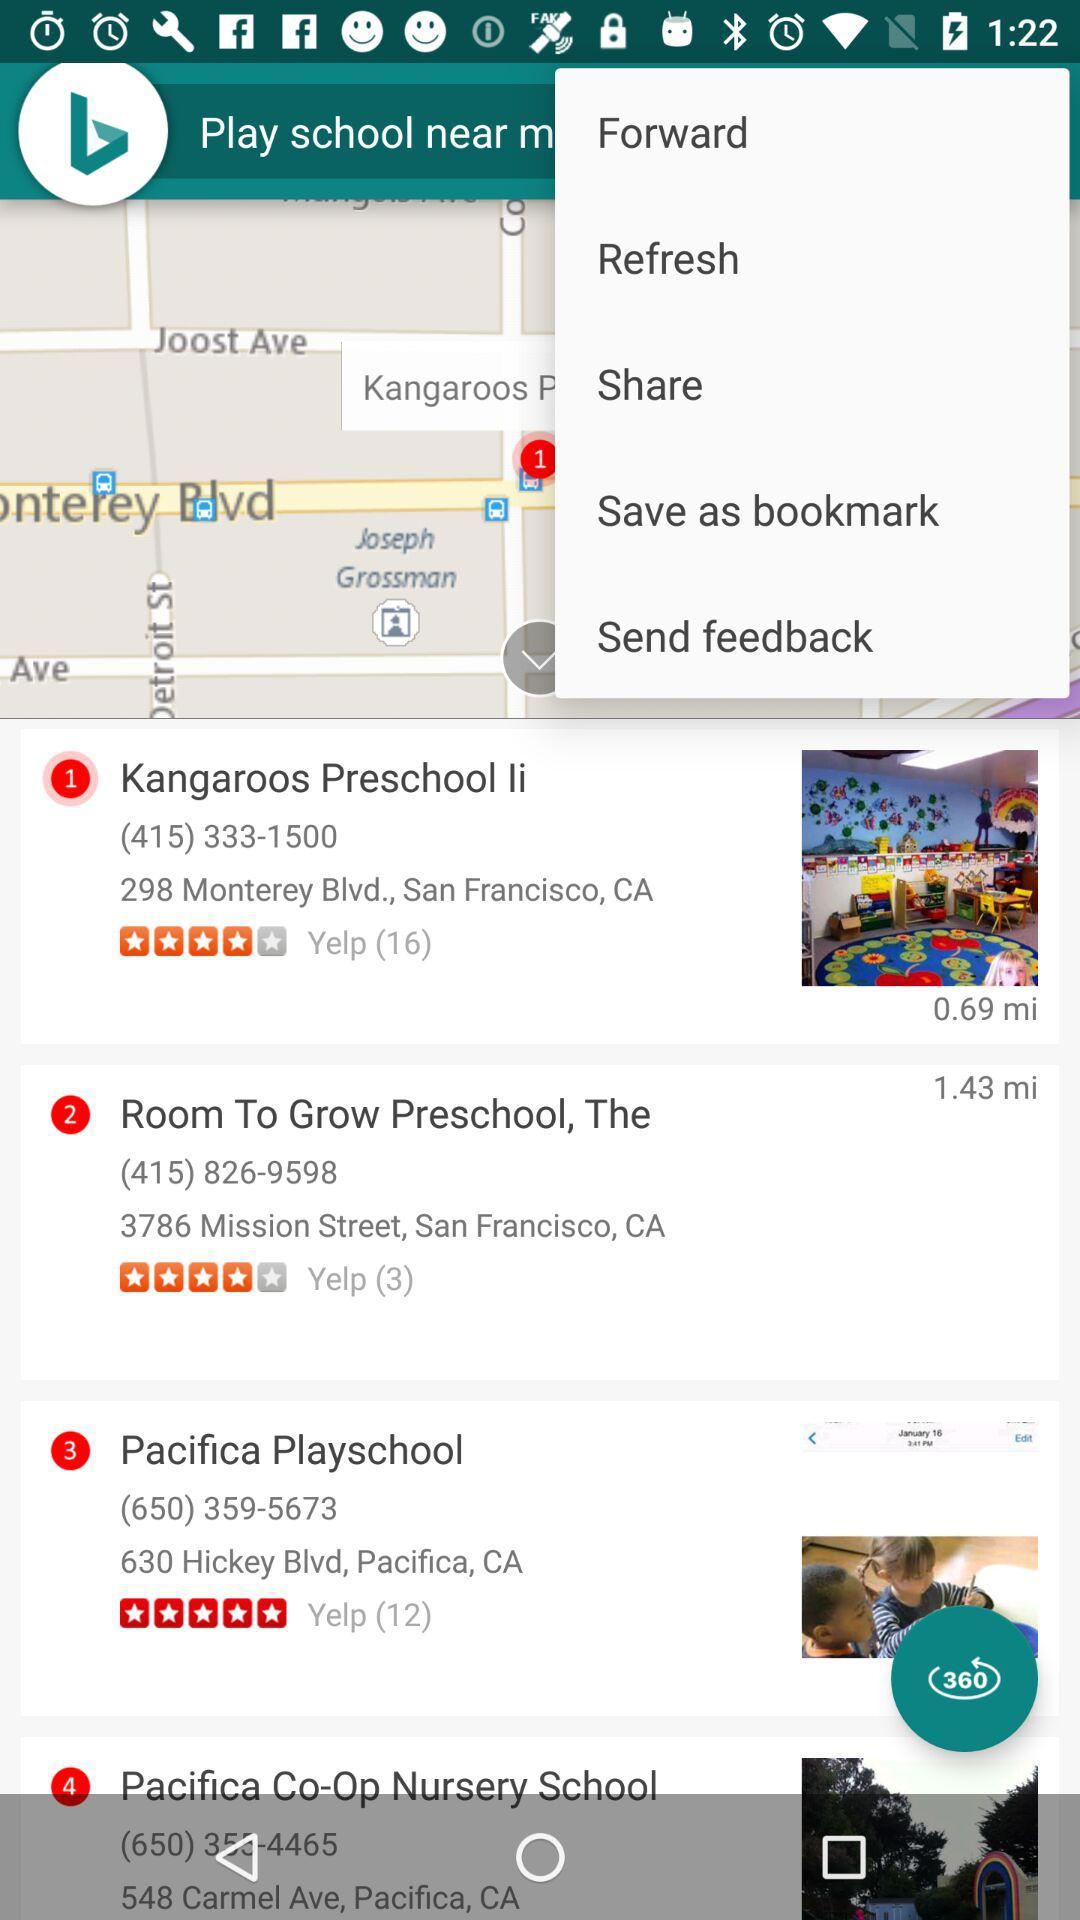What is the location of "Room to Grow Preschool"? The location of "Room to Grow Preschool" is 3786 Mission Street, San Francisco, CA. 